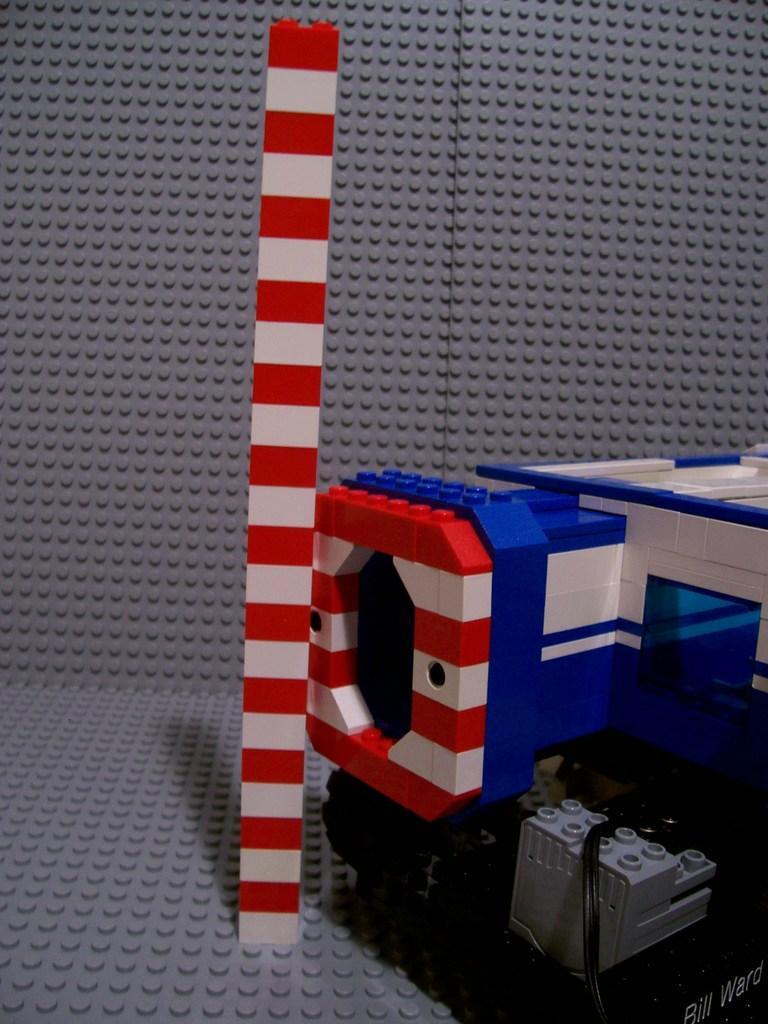How would you summarize this image in a sentence or two? In this picture we can see a pole and few objects made of a Lego. 